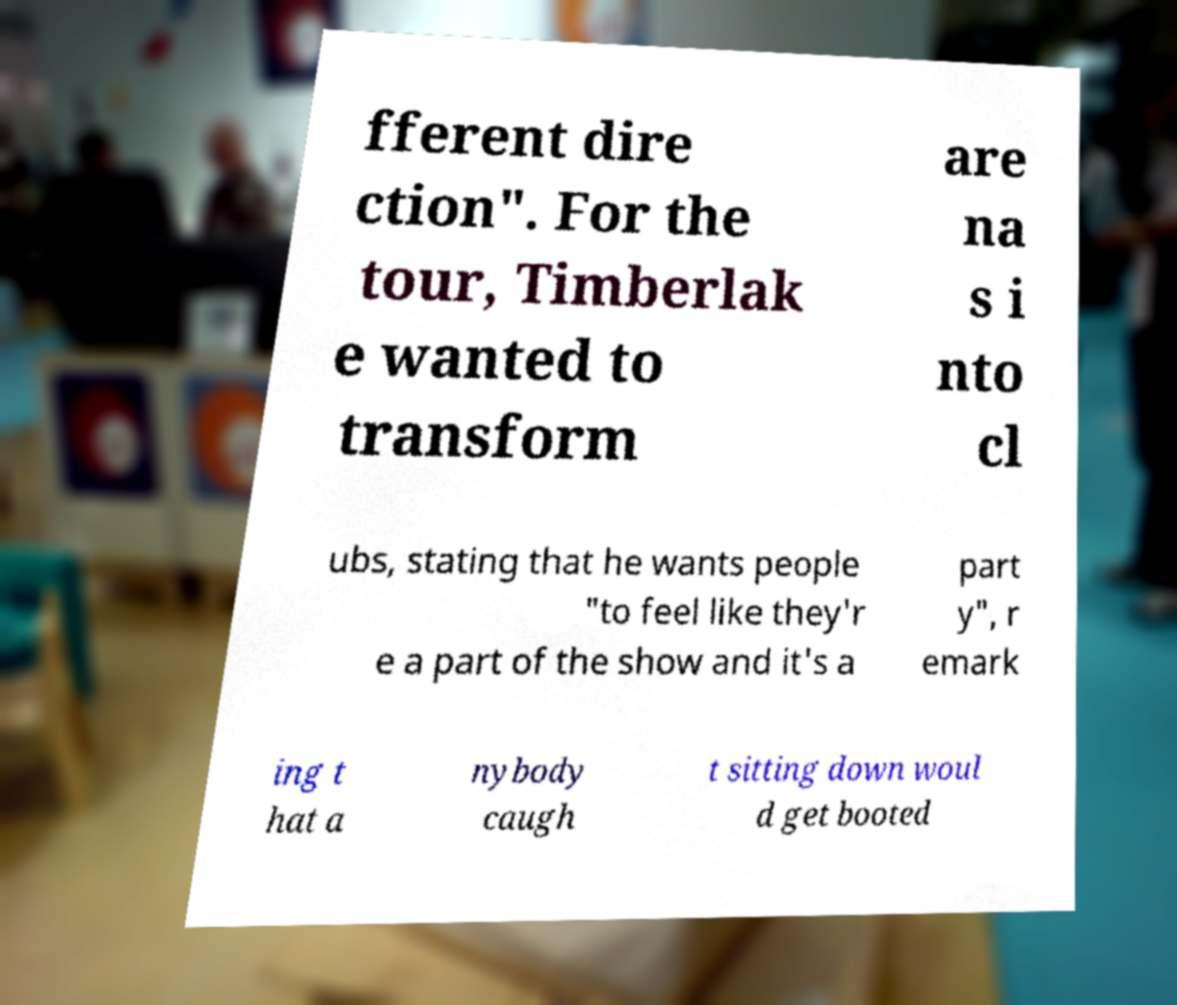What messages or text are displayed in this image? I need them in a readable, typed format. fferent dire ction". For the tour, Timberlak e wanted to transform are na s i nto cl ubs, stating that he wants people "to feel like they'r e a part of the show and it's a part y", r emark ing t hat a nybody caugh t sitting down woul d get booted 